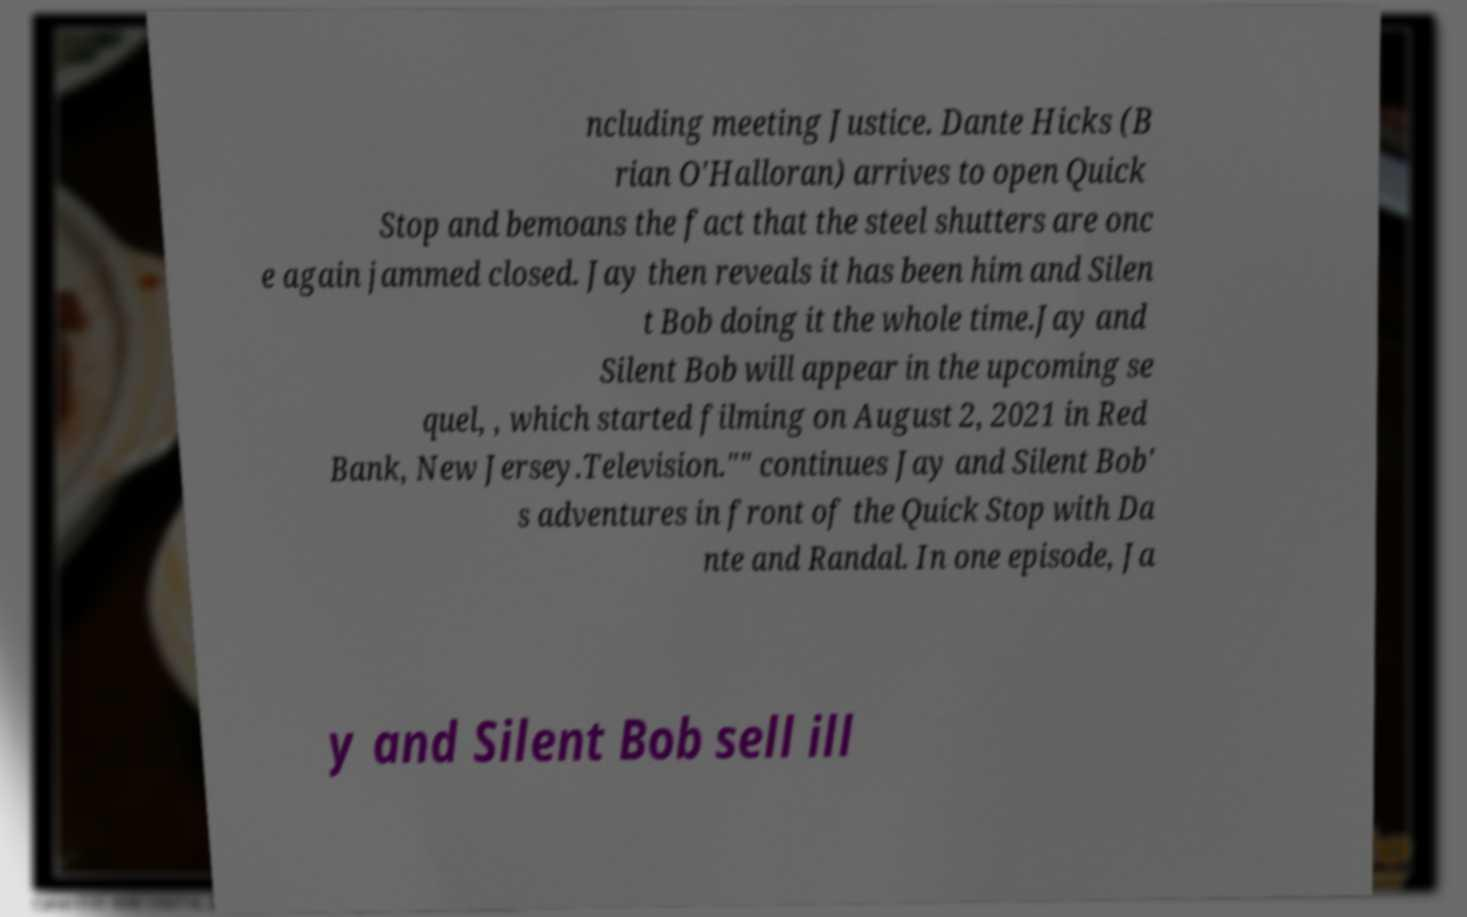Could you extract and type out the text from this image? ncluding meeting Justice. Dante Hicks (B rian O'Halloran) arrives to open Quick Stop and bemoans the fact that the steel shutters are onc e again jammed closed. Jay then reveals it has been him and Silen t Bob doing it the whole time.Jay and Silent Bob will appear in the upcoming se quel, , which started filming on August 2, 2021 in Red Bank, New Jersey.Television."" continues Jay and Silent Bob' s adventures in front of the Quick Stop with Da nte and Randal. In one episode, Ja y and Silent Bob sell ill 